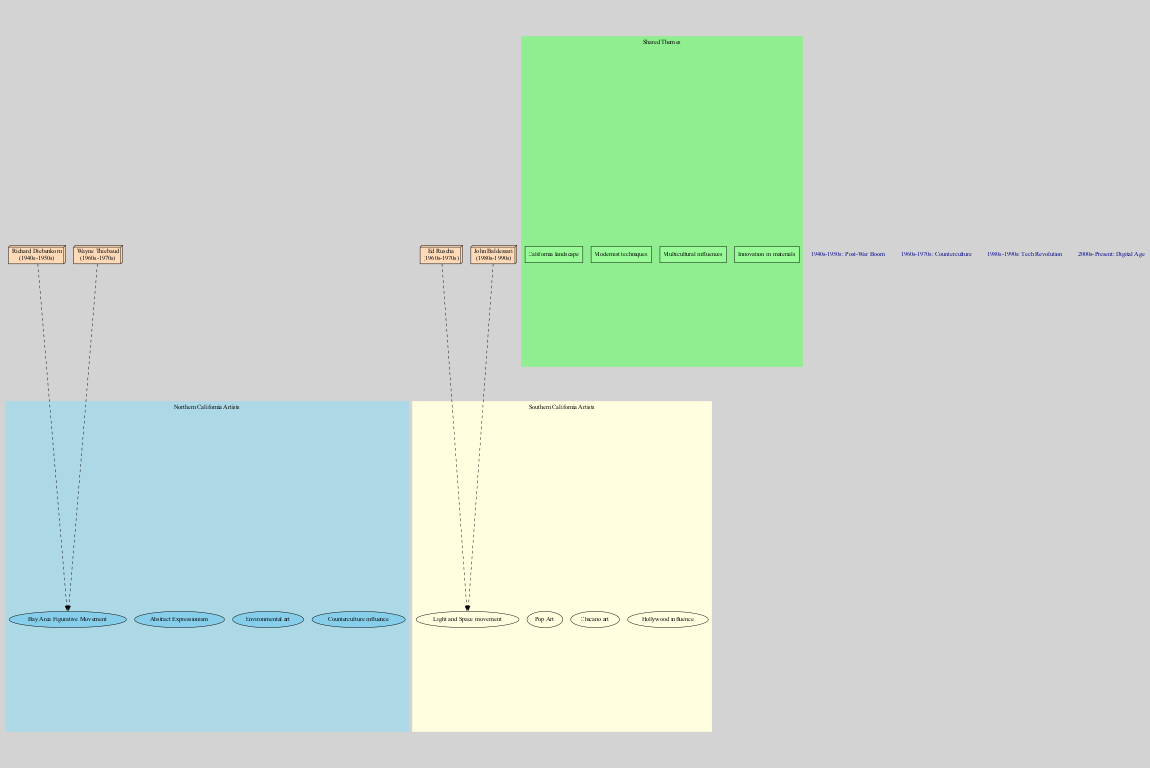What artistic movement is associated with Northern California artists? The diagram indicates that the Bay Area Figurative Movement is an artistic movement associated with Northern California artists. This is located within the relevant subgraph labeled "Northern California Artists."
Answer: Bay Area Figurative Movement Which era corresponds to the emergence of Pop Art? According to the diagram's details, Pop Art is tied to the Southern California arts scene; the relevant era is the 1960s-1970s, which is specified in the "eras" section.
Answer: 1960s-1970s How many shared themes are depicted in the diagram? The diagram includes a subgraph labeled "Shared Themes," containing four specific elements: California landscape, Modernist techniques, Multicultural influences, and Innovation in materials. Counting these reveals a total of four themes.
Answer: 4 Which key artist from Southern California is linked to the 1980s-1990s era? By referencing the key artists in the diagram, John Baldessari is identified as the Southern California artist associated with the 1980s-1990s, as his details are presented alongside that era.
Answer: John Baldessari What common element connects Northern and Southern California artists? The shared themes node reveals that California landscape is an element both regions have in common, highlighting its significance in their respective artistic expressions.
Answer: California landscape Which artistic style is unique to Southern California artists as shown in the diagram? The Light and Space movement appears exclusively within the Southern California section, making it a distinctive artistic style for this region compared to Northern California arts.
Answer: Light and Space movement In how many different eras have Northern California artists produced significant works? The diagram indicates four defined eras that represent artistic production: 1940s-1950s, 1960s-1970s, 1980s-1990s, and 2000s-Present. This indicates that Northern California artists have worked across all four specified eras.
Answer: 4 Which technique is a shared element between Northern and Southern California artists? Within the "Shared Themes" section, Modernist techniques are listed as a common element, indicating that both Northern and Southern California artists utilize this technique in their works.
Answer: Modernist techniques 